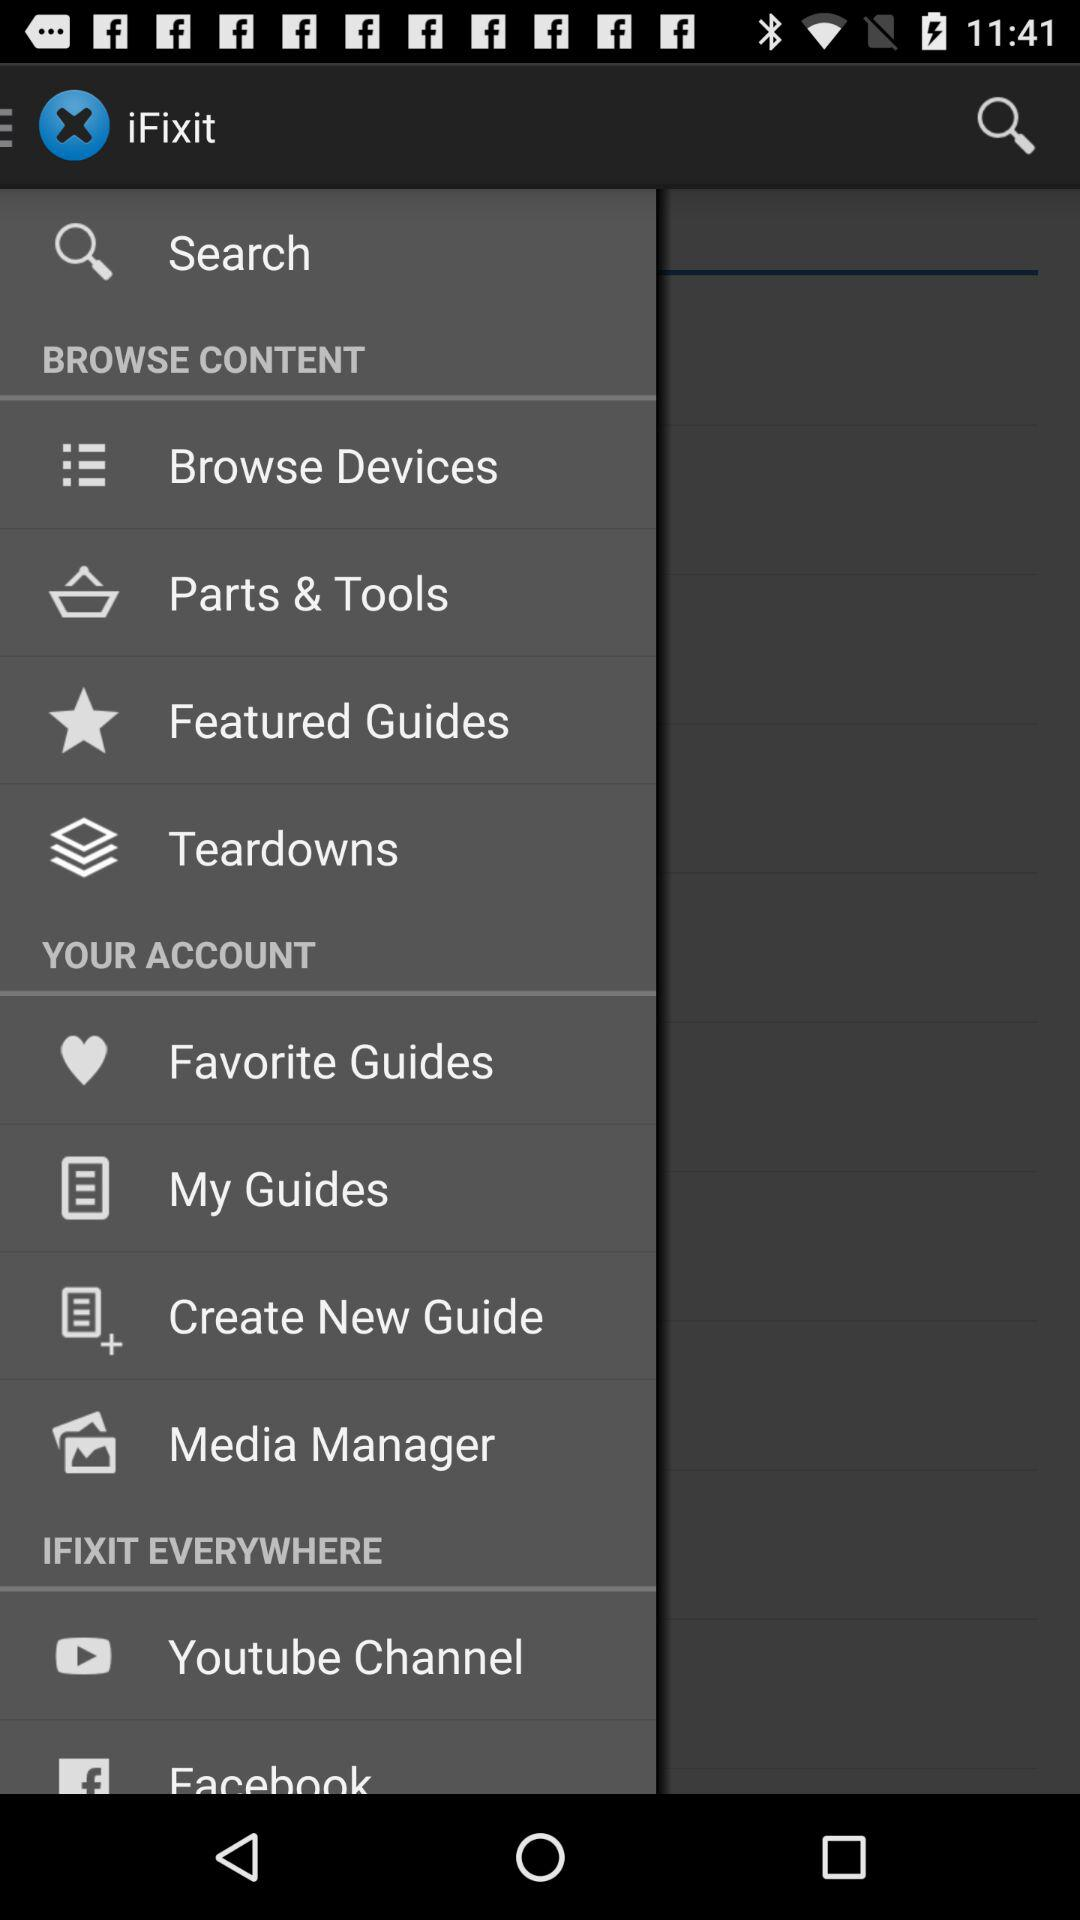What is the application name? The application name is "iFixit". 